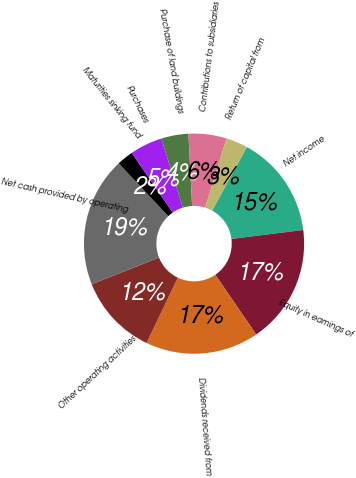<chart> <loc_0><loc_0><loc_500><loc_500><pie_chart><fcel>Net income<fcel>Equity in earnings of<fcel>Dividends received from<fcel>Other operating activities<fcel>Net cash provided by operating<fcel>Maturities sinking fund<fcel>Purchases<fcel>Purchase of land buildings<fcel>Contributions to subsidiaries<fcel>Return of capital from<nl><fcel>15.06%<fcel>17.43%<fcel>16.64%<fcel>11.9%<fcel>19.01%<fcel>2.41%<fcel>4.78%<fcel>3.99%<fcel>5.57%<fcel>3.2%<nl></chart> 